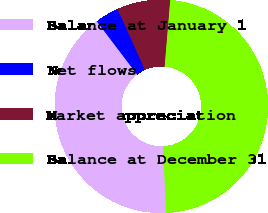<chart> <loc_0><loc_0><loc_500><loc_500><pie_chart><fcel>Balance at January 1<fcel>Net flows<fcel>Market appreciation<fcel>Balance at December 31<nl><fcel>40.38%<fcel>3.62%<fcel>8.05%<fcel>47.95%<nl></chart> 